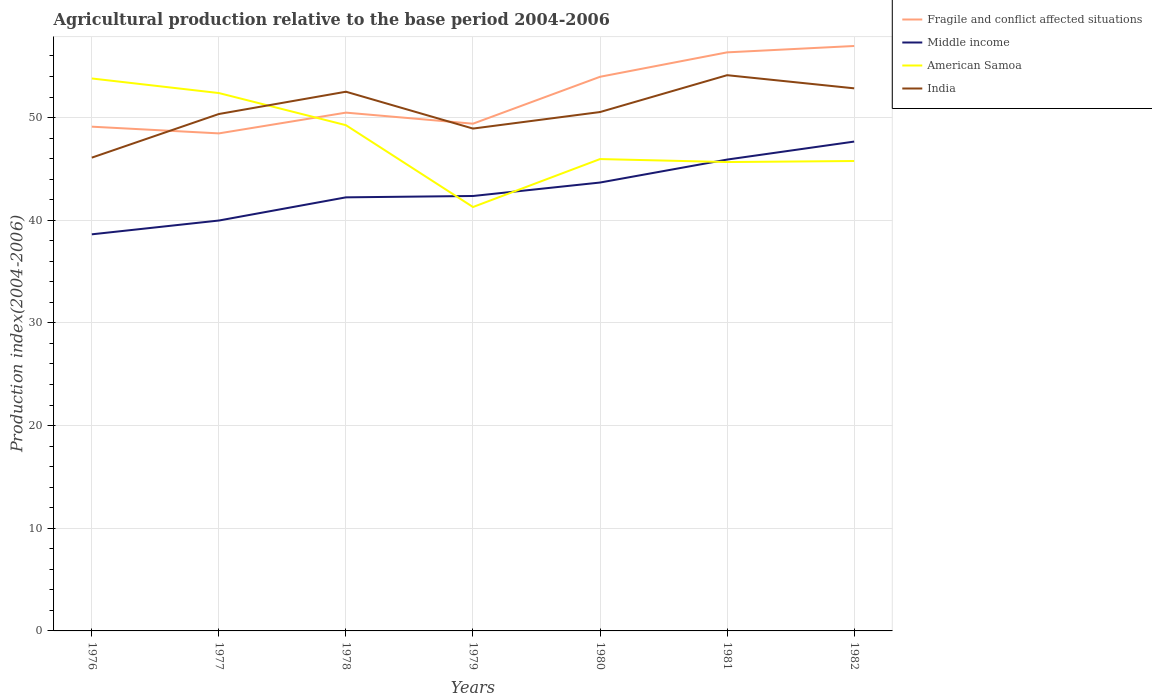Is the number of lines equal to the number of legend labels?
Provide a short and direct response. Yes. Across all years, what is the maximum agricultural production index in Middle income?
Offer a very short reply. 38.63. In which year was the agricultural production index in Middle income maximum?
Provide a succinct answer. 1976. What is the total agricultural production index in India in the graph?
Provide a short and direct response. -2.31. What is the difference between the highest and the second highest agricultural production index in Middle income?
Give a very brief answer. 9.03. How many lines are there?
Provide a succinct answer. 4. How many years are there in the graph?
Give a very brief answer. 7. What is the difference between two consecutive major ticks on the Y-axis?
Provide a short and direct response. 10. Where does the legend appear in the graph?
Your response must be concise. Top right. What is the title of the graph?
Offer a very short reply. Agricultural production relative to the base period 2004-2006. Does "Peru" appear as one of the legend labels in the graph?
Your answer should be compact. No. What is the label or title of the X-axis?
Make the answer very short. Years. What is the label or title of the Y-axis?
Your response must be concise. Production index(2004-2006). What is the Production index(2004-2006) in Fragile and conflict affected situations in 1976?
Make the answer very short. 49.11. What is the Production index(2004-2006) in Middle income in 1976?
Make the answer very short. 38.63. What is the Production index(2004-2006) of American Samoa in 1976?
Offer a very short reply. 53.81. What is the Production index(2004-2006) in India in 1976?
Your answer should be compact. 46.1. What is the Production index(2004-2006) of Fragile and conflict affected situations in 1977?
Keep it short and to the point. 48.46. What is the Production index(2004-2006) of Middle income in 1977?
Offer a terse response. 39.97. What is the Production index(2004-2006) in American Samoa in 1977?
Offer a terse response. 52.39. What is the Production index(2004-2006) of India in 1977?
Give a very brief answer. 50.35. What is the Production index(2004-2006) of Fragile and conflict affected situations in 1978?
Keep it short and to the point. 50.48. What is the Production index(2004-2006) in Middle income in 1978?
Ensure brevity in your answer.  42.23. What is the Production index(2004-2006) of American Samoa in 1978?
Make the answer very short. 49.26. What is the Production index(2004-2006) in India in 1978?
Ensure brevity in your answer.  52.52. What is the Production index(2004-2006) of Fragile and conflict affected situations in 1979?
Offer a terse response. 49.41. What is the Production index(2004-2006) in Middle income in 1979?
Offer a very short reply. 42.36. What is the Production index(2004-2006) of American Samoa in 1979?
Keep it short and to the point. 41.29. What is the Production index(2004-2006) of India in 1979?
Offer a terse response. 48.93. What is the Production index(2004-2006) in Fragile and conflict affected situations in 1980?
Provide a short and direct response. 53.98. What is the Production index(2004-2006) of Middle income in 1980?
Ensure brevity in your answer.  43.67. What is the Production index(2004-2006) of American Samoa in 1980?
Offer a terse response. 45.96. What is the Production index(2004-2006) in India in 1980?
Your answer should be compact. 50.54. What is the Production index(2004-2006) in Fragile and conflict affected situations in 1981?
Provide a short and direct response. 56.35. What is the Production index(2004-2006) in Middle income in 1981?
Offer a very short reply. 45.91. What is the Production index(2004-2006) in American Samoa in 1981?
Give a very brief answer. 45.67. What is the Production index(2004-2006) of India in 1981?
Give a very brief answer. 54.13. What is the Production index(2004-2006) in Fragile and conflict affected situations in 1982?
Give a very brief answer. 56.97. What is the Production index(2004-2006) of Middle income in 1982?
Your answer should be very brief. 47.66. What is the Production index(2004-2006) of American Samoa in 1982?
Give a very brief answer. 45.77. What is the Production index(2004-2006) in India in 1982?
Offer a terse response. 52.85. Across all years, what is the maximum Production index(2004-2006) of Fragile and conflict affected situations?
Give a very brief answer. 56.97. Across all years, what is the maximum Production index(2004-2006) in Middle income?
Your answer should be compact. 47.66. Across all years, what is the maximum Production index(2004-2006) of American Samoa?
Offer a very short reply. 53.81. Across all years, what is the maximum Production index(2004-2006) in India?
Offer a terse response. 54.13. Across all years, what is the minimum Production index(2004-2006) of Fragile and conflict affected situations?
Make the answer very short. 48.46. Across all years, what is the minimum Production index(2004-2006) in Middle income?
Your response must be concise. 38.63. Across all years, what is the minimum Production index(2004-2006) of American Samoa?
Ensure brevity in your answer.  41.29. Across all years, what is the minimum Production index(2004-2006) in India?
Give a very brief answer. 46.1. What is the total Production index(2004-2006) of Fragile and conflict affected situations in the graph?
Offer a terse response. 364.77. What is the total Production index(2004-2006) in Middle income in the graph?
Provide a short and direct response. 300.45. What is the total Production index(2004-2006) of American Samoa in the graph?
Keep it short and to the point. 334.15. What is the total Production index(2004-2006) of India in the graph?
Give a very brief answer. 355.42. What is the difference between the Production index(2004-2006) of Fragile and conflict affected situations in 1976 and that in 1977?
Ensure brevity in your answer.  0.65. What is the difference between the Production index(2004-2006) in Middle income in 1976 and that in 1977?
Make the answer very short. -1.34. What is the difference between the Production index(2004-2006) in American Samoa in 1976 and that in 1977?
Keep it short and to the point. 1.42. What is the difference between the Production index(2004-2006) of India in 1976 and that in 1977?
Provide a succinct answer. -4.25. What is the difference between the Production index(2004-2006) in Fragile and conflict affected situations in 1976 and that in 1978?
Your answer should be compact. -1.37. What is the difference between the Production index(2004-2006) in Middle income in 1976 and that in 1978?
Keep it short and to the point. -3.6. What is the difference between the Production index(2004-2006) of American Samoa in 1976 and that in 1978?
Ensure brevity in your answer.  4.55. What is the difference between the Production index(2004-2006) in India in 1976 and that in 1978?
Provide a short and direct response. -6.42. What is the difference between the Production index(2004-2006) of Fragile and conflict affected situations in 1976 and that in 1979?
Offer a terse response. -0.29. What is the difference between the Production index(2004-2006) in Middle income in 1976 and that in 1979?
Ensure brevity in your answer.  -3.73. What is the difference between the Production index(2004-2006) in American Samoa in 1976 and that in 1979?
Keep it short and to the point. 12.52. What is the difference between the Production index(2004-2006) of India in 1976 and that in 1979?
Keep it short and to the point. -2.83. What is the difference between the Production index(2004-2006) in Fragile and conflict affected situations in 1976 and that in 1980?
Provide a short and direct response. -4.86. What is the difference between the Production index(2004-2006) in Middle income in 1976 and that in 1980?
Give a very brief answer. -5.04. What is the difference between the Production index(2004-2006) in American Samoa in 1976 and that in 1980?
Provide a succinct answer. 7.85. What is the difference between the Production index(2004-2006) of India in 1976 and that in 1980?
Your answer should be compact. -4.44. What is the difference between the Production index(2004-2006) of Fragile and conflict affected situations in 1976 and that in 1981?
Keep it short and to the point. -7.24. What is the difference between the Production index(2004-2006) of Middle income in 1976 and that in 1981?
Offer a terse response. -7.28. What is the difference between the Production index(2004-2006) in American Samoa in 1976 and that in 1981?
Offer a very short reply. 8.14. What is the difference between the Production index(2004-2006) in India in 1976 and that in 1981?
Your response must be concise. -8.03. What is the difference between the Production index(2004-2006) of Fragile and conflict affected situations in 1976 and that in 1982?
Keep it short and to the point. -7.86. What is the difference between the Production index(2004-2006) of Middle income in 1976 and that in 1982?
Ensure brevity in your answer.  -9.03. What is the difference between the Production index(2004-2006) in American Samoa in 1976 and that in 1982?
Ensure brevity in your answer.  8.04. What is the difference between the Production index(2004-2006) in India in 1976 and that in 1982?
Provide a short and direct response. -6.75. What is the difference between the Production index(2004-2006) in Fragile and conflict affected situations in 1977 and that in 1978?
Your answer should be very brief. -2.02. What is the difference between the Production index(2004-2006) in Middle income in 1977 and that in 1978?
Provide a succinct answer. -2.26. What is the difference between the Production index(2004-2006) in American Samoa in 1977 and that in 1978?
Your response must be concise. 3.13. What is the difference between the Production index(2004-2006) of India in 1977 and that in 1978?
Give a very brief answer. -2.17. What is the difference between the Production index(2004-2006) in Fragile and conflict affected situations in 1977 and that in 1979?
Make the answer very short. -0.94. What is the difference between the Production index(2004-2006) of Middle income in 1977 and that in 1979?
Offer a terse response. -2.39. What is the difference between the Production index(2004-2006) in India in 1977 and that in 1979?
Ensure brevity in your answer.  1.42. What is the difference between the Production index(2004-2006) in Fragile and conflict affected situations in 1977 and that in 1980?
Offer a very short reply. -5.51. What is the difference between the Production index(2004-2006) in Middle income in 1977 and that in 1980?
Provide a succinct answer. -3.7. What is the difference between the Production index(2004-2006) of American Samoa in 1977 and that in 1980?
Make the answer very short. 6.43. What is the difference between the Production index(2004-2006) in India in 1977 and that in 1980?
Provide a succinct answer. -0.19. What is the difference between the Production index(2004-2006) of Fragile and conflict affected situations in 1977 and that in 1981?
Offer a very short reply. -7.89. What is the difference between the Production index(2004-2006) in Middle income in 1977 and that in 1981?
Ensure brevity in your answer.  -5.94. What is the difference between the Production index(2004-2006) in American Samoa in 1977 and that in 1981?
Make the answer very short. 6.72. What is the difference between the Production index(2004-2006) of India in 1977 and that in 1981?
Your answer should be very brief. -3.78. What is the difference between the Production index(2004-2006) of Fragile and conflict affected situations in 1977 and that in 1982?
Give a very brief answer. -8.51. What is the difference between the Production index(2004-2006) of Middle income in 1977 and that in 1982?
Offer a very short reply. -7.69. What is the difference between the Production index(2004-2006) of American Samoa in 1977 and that in 1982?
Ensure brevity in your answer.  6.62. What is the difference between the Production index(2004-2006) in Fragile and conflict affected situations in 1978 and that in 1979?
Keep it short and to the point. 1.08. What is the difference between the Production index(2004-2006) in Middle income in 1978 and that in 1979?
Give a very brief answer. -0.13. What is the difference between the Production index(2004-2006) of American Samoa in 1978 and that in 1979?
Keep it short and to the point. 7.97. What is the difference between the Production index(2004-2006) of India in 1978 and that in 1979?
Provide a succinct answer. 3.59. What is the difference between the Production index(2004-2006) of Fragile and conflict affected situations in 1978 and that in 1980?
Offer a terse response. -3.49. What is the difference between the Production index(2004-2006) of Middle income in 1978 and that in 1980?
Provide a short and direct response. -1.44. What is the difference between the Production index(2004-2006) of American Samoa in 1978 and that in 1980?
Give a very brief answer. 3.3. What is the difference between the Production index(2004-2006) in India in 1978 and that in 1980?
Offer a very short reply. 1.98. What is the difference between the Production index(2004-2006) of Fragile and conflict affected situations in 1978 and that in 1981?
Keep it short and to the point. -5.87. What is the difference between the Production index(2004-2006) of Middle income in 1978 and that in 1981?
Offer a very short reply. -3.68. What is the difference between the Production index(2004-2006) of American Samoa in 1978 and that in 1981?
Offer a very short reply. 3.59. What is the difference between the Production index(2004-2006) in India in 1978 and that in 1981?
Give a very brief answer. -1.61. What is the difference between the Production index(2004-2006) of Fragile and conflict affected situations in 1978 and that in 1982?
Give a very brief answer. -6.49. What is the difference between the Production index(2004-2006) of Middle income in 1978 and that in 1982?
Your response must be concise. -5.43. What is the difference between the Production index(2004-2006) of American Samoa in 1978 and that in 1982?
Your response must be concise. 3.49. What is the difference between the Production index(2004-2006) in India in 1978 and that in 1982?
Offer a terse response. -0.33. What is the difference between the Production index(2004-2006) of Fragile and conflict affected situations in 1979 and that in 1980?
Make the answer very short. -4.57. What is the difference between the Production index(2004-2006) in Middle income in 1979 and that in 1980?
Ensure brevity in your answer.  -1.31. What is the difference between the Production index(2004-2006) of American Samoa in 1979 and that in 1980?
Your answer should be very brief. -4.67. What is the difference between the Production index(2004-2006) of India in 1979 and that in 1980?
Provide a succinct answer. -1.61. What is the difference between the Production index(2004-2006) in Fragile and conflict affected situations in 1979 and that in 1981?
Your answer should be compact. -6.95. What is the difference between the Production index(2004-2006) of Middle income in 1979 and that in 1981?
Offer a terse response. -3.55. What is the difference between the Production index(2004-2006) of American Samoa in 1979 and that in 1981?
Offer a terse response. -4.38. What is the difference between the Production index(2004-2006) of Fragile and conflict affected situations in 1979 and that in 1982?
Your answer should be compact. -7.57. What is the difference between the Production index(2004-2006) of Middle income in 1979 and that in 1982?
Give a very brief answer. -5.3. What is the difference between the Production index(2004-2006) of American Samoa in 1979 and that in 1982?
Give a very brief answer. -4.48. What is the difference between the Production index(2004-2006) of India in 1979 and that in 1982?
Offer a terse response. -3.92. What is the difference between the Production index(2004-2006) in Fragile and conflict affected situations in 1980 and that in 1981?
Offer a very short reply. -2.38. What is the difference between the Production index(2004-2006) of Middle income in 1980 and that in 1981?
Keep it short and to the point. -2.24. What is the difference between the Production index(2004-2006) of American Samoa in 1980 and that in 1981?
Your answer should be very brief. 0.29. What is the difference between the Production index(2004-2006) in India in 1980 and that in 1981?
Give a very brief answer. -3.59. What is the difference between the Production index(2004-2006) of Fragile and conflict affected situations in 1980 and that in 1982?
Provide a short and direct response. -3. What is the difference between the Production index(2004-2006) of Middle income in 1980 and that in 1982?
Offer a terse response. -3.99. What is the difference between the Production index(2004-2006) of American Samoa in 1980 and that in 1982?
Offer a terse response. 0.19. What is the difference between the Production index(2004-2006) of India in 1980 and that in 1982?
Your answer should be very brief. -2.31. What is the difference between the Production index(2004-2006) in Fragile and conflict affected situations in 1981 and that in 1982?
Ensure brevity in your answer.  -0.62. What is the difference between the Production index(2004-2006) in Middle income in 1981 and that in 1982?
Keep it short and to the point. -1.75. What is the difference between the Production index(2004-2006) in India in 1981 and that in 1982?
Provide a succinct answer. 1.28. What is the difference between the Production index(2004-2006) in Fragile and conflict affected situations in 1976 and the Production index(2004-2006) in Middle income in 1977?
Offer a very short reply. 9.14. What is the difference between the Production index(2004-2006) in Fragile and conflict affected situations in 1976 and the Production index(2004-2006) in American Samoa in 1977?
Ensure brevity in your answer.  -3.28. What is the difference between the Production index(2004-2006) of Fragile and conflict affected situations in 1976 and the Production index(2004-2006) of India in 1977?
Give a very brief answer. -1.24. What is the difference between the Production index(2004-2006) of Middle income in 1976 and the Production index(2004-2006) of American Samoa in 1977?
Offer a terse response. -13.76. What is the difference between the Production index(2004-2006) of Middle income in 1976 and the Production index(2004-2006) of India in 1977?
Offer a terse response. -11.72. What is the difference between the Production index(2004-2006) of American Samoa in 1976 and the Production index(2004-2006) of India in 1977?
Offer a very short reply. 3.46. What is the difference between the Production index(2004-2006) of Fragile and conflict affected situations in 1976 and the Production index(2004-2006) of Middle income in 1978?
Keep it short and to the point. 6.88. What is the difference between the Production index(2004-2006) in Fragile and conflict affected situations in 1976 and the Production index(2004-2006) in American Samoa in 1978?
Your response must be concise. -0.15. What is the difference between the Production index(2004-2006) of Fragile and conflict affected situations in 1976 and the Production index(2004-2006) of India in 1978?
Your answer should be very brief. -3.41. What is the difference between the Production index(2004-2006) of Middle income in 1976 and the Production index(2004-2006) of American Samoa in 1978?
Offer a very short reply. -10.63. What is the difference between the Production index(2004-2006) in Middle income in 1976 and the Production index(2004-2006) in India in 1978?
Give a very brief answer. -13.89. What is the difference between the Production index(2004-2006) of American Samoa in 1976 and the Production index(2004-2006) of India in 1978?
Your answer should be very brief. 1.29. What is the difference between the Production index(2004-2006) in Fragile and conflict affected situations in 1976 and the Production index(2004-2006) in Middle income in 1979?
Offer a terse response. 6.75. What is the difference between the Production index(2004-2006) in Fragile and conflict affected situations in 1976 and the Production index(2004-2006) in American Samoa in 1979?
Your answer should be very brief. 7.82. What is the difference between the Production index(2004-2006) in Fragile and conflict affected situations in 1976 and the Production index(2004-2006) in India in 1979?
Make the answer very short. 0.18. What is the difference between the Production index(2004-2006) of Middle income in 1976 and the Production index(2004-2006) of American Samoa in 1979?
Offer a terse response. -2.66. What is the difference between the Production index(2004-2006) of Middle income in 1976 and the Production index(2004-2006) of India in 1979?
Offer a very short reply. -10.3. What is the difference between the Production index(2004-2006) of American Samoa in 1976 and the Production index(2004-2006) of India in 1979?
Your answer should be very brief. 4.88. What is the difference between the Production index(2004-2006) in Fragile and conflict affected situations in 1976 and the Production index(2004-2006) in Middle income in 1980?
Your response must be concise. 5.44. What is the difference between the Production index(2004-2006) in Fragile and conflict affected situations in 1976 and the Production index(2004-2006) in American Samoa in 1980?
Make the answer very short. 3.15. What is the difference between the Production index(2004-2006) of Fragile and conflict affected situations in 1976 and the Production index(2004-2006) of India in 1980?
Give a very brief answer. -1.43. What is the difference between the Production index(2004-2006) of Middle income in 1976 and the Production index(2004-2006) of American Samoa in 1980?
Your answer should be very brief. -7.33. What is the difference between the Production index(2004-2006) of Middle income in 1976 and the Production index(2004-2006) of India in 1980?
Give a very brief answer. -11.91. What is the difference between the Production index(2004-2006) of American Samoa in 1976 and the Production index(2004-2006) of India in 1980?
Ensure brevity in your answer.  3.27. What is the difference between the Production index(2004-2006) of Fragile and conflict affected situations in 1976 and the Production index(2004-2006) of Middle income in 1981?
Provide a succinct answer. 3.2. What is the difference between the Production index(2004-2006) in Fragile and conflict affected situations in 1976 and the Production index(2004-2006) in American Samoa in 1981?
Your answer should be very brief. 3.44. What is the difference between the Production index(2004-2006) of Fragile and conflict affected situations in 1976 and the Production index(2004-2006) of India in 1981?
Offer a terse response. -5.02. What is the difference between the Production index(2004-2006) in Middle income in 1976 and the Production index(2004-2006) in American Samoa in 1981?
Keep it short and to the point. -7.04. What is the difference between the Production index(2004-2006) in Middle income in 1976 and the Production index(2004-2006) in India in 1981?
Keep it short and to the point. -15.5. What is the difference between the Production index(2004-2006) in American Samoa in 1976 and the Production index(2004-2006) in India in 1981?
Provide a succinct answer. -0.32. What is the difference between the Production index(2004-2006) in Fragile and conflict affected situations in 1976 and the Production index(2004-2006) in Middle income in 1982?
Make the answer very short. 1.45. What is the difference between the Production index(2004-2006) in Fragile and conflict affected situations in 1976 and the Production index(2004-2006) in American Samoa in 1982?
Ensure brevity in your answer.  3.34. What is the difference between the Production index(2004-2006) of Fragile and conflict affected situations in 1976 and the Production index(2004-2006) of India in 1982?
Your answer should be very brief. -3.74. What is the difference between the Production index(2004-2006) in Middle income in 1976 and the Production index(2004-2006) in American Samoa in 1982?
Make the answer very short. -7.14. What is the difference between the Production index(2004-2006) of Middle income in 1976 and the Production index(2004-2006) of India in 1982?
Provide a succinct answer. -14.22. What is the difference between the Production index(2004-2006) in American Samoa in 1976 and the Production index(2004-2006) in India in 1982?
Keep it short and to the point. 0.96. What is the difference between the Production index(2004-2006) of Fragile and conflict affected situations in 1977 and the Production index(2004-2006) of Middle income in 1978?
Ensure brevity in your answer.  6.23. What is the difference between the Production index(2004-2006) in Fragile and conflict affected situations in 1977 and the Production index(2004-2006) in American Samoa in 1978?
Your answer should be very brief. -0.8. What is the difference between the Production index(2004-2006) in Fragile and conflict affected situations in 1977 and the Production index(2004-2006) in India in 1978?
Ensure brevity in your answer.  -4.06. What is the difference between the Production index(2004-2006) in Middle income in 1977 and the Production index(2004-2006) in American Samoa in 1978?
Provide a succinct answer. -9.29. What is the difference between the Production index(2004-2006) of Middle income in 1977 and the Production index(2004-2006) of India in 1978?
Offer a very short reply. -12.55. What is the difference between the Production index(2004-2006) of American Samoa in 1977 and the Production index(2004-2006) of India in 1978?
Your response must be concise. -0.13. What is the difference between the Production index(2004-2006) in Fragile and conflict affected situations in 1977 and the Production index(2004-2006) in Middle income in 1979?
Offer a terse response. 6.1. What is the difference between the Production index(2004-2006) in Fragile and conflict affected situations in 1977 and the Production index(2004-2006) in American Samoa in 1979?
Your response must be concise. 7.17. What is the difference between the Production index(2004-2006) in Fragile and conflict affected situations in 1977 and the Production index(2004-2006) in India in 1979?
Keep it short and to the point. -0.47. What is the difference between the Production index(2004-2006) of Middle income in 1977 and the Production index(2004-2006) of American Samoa in 1979?
Make the answer very short. -1.32. What is the difference between the Production index(2004-2006) in Middle income in 1977 and the Production index(2004-2006) in India in 1979?
Keep it short and to the point. -8.96. What is the difference between the Production index(2004-2006) in American Samoa in 1977 and the Production index(2004-2006) in India in 1979?
Your answer should be very brief. 3.46. What is the difference between the Production index(2004-2006) of Fragile and conflict affected situations in 1977 and the Production index(2004-2006) of Middle income in 1980?
Provide a short and direct response. 4.79. What is the difference between the Production index(2004-2006) in Fragile and conflict affected situations in 1977 and the Production index(2004-2006) in American Samoa in 1980?
Offer a very short reply. 2.5. What is the difference between the Production index(2004-2006) of Fragile and conflict affected situations in 1977 and the Production index(2004-2006) of India in 1980?
Your answer should be compact. -2.08. What is the difference between the Production index(2004-2006) in Middle income in 1977 and the Production index(2004-2006) in American Samoa in 1980?
Keep it short and to the point. -5.99. What is the difference between the Production index(2004-2006) in Middle income in 1977 and the Production index(2004-2006) in India in 1980?
Offer a terse response. -10.57. What is the difference between the Production index(2004-2006) in American Samoa in 1977 and the Production index(2004-2006) in India in 1980?
Offer a very short reply. 1.85. What is the difference between the Production index(2004-2006) of Fragile and conflict affected situations in 1977 and the Production index(2004-2006) of Middle income in 1981?
Offer a very short reply. 2.55. What is the difference between the Production index(2004-2006) of Fragile and conflict affected situations in 1977 and the Production index(2004-2006) of American Samoa in 1981?
Keep it short and to the point. 2.79. What is the difference between the Production index(2004-2006) of Fragile and conflict affected situations in 1977 and the Production index(2004-2006) of India in 1981?
Offer a terse response. -5.67. What is the difference between the Production index(2004-2006) in Middle income in 1977 and the Production index(2004-2006) in American Samoa in 1981?
Make the answer very short. -5.7. What is the difference between the Production index(2004-2006) of Middle income in 1977 and the Production index(2004-2006) of India in 1981?
Provide a succinct answer. -14.16. What is the difference between the Production index(2004-2006) of American Samoa in 1977 and the Production index(2004-2006) of India in 1981?
Keep it short and to the point. -1.74. What is the difference between the Production index(2004-2006) of Fragile and conflict affected situations in 1977 and the Production index(2004-2006) of Middle income in 1982?
Offer a terse response. 0.8. What is the difference between the Production index(2004-2006) of Fragile and conflict affected situations in 1977 and the Production index(2004-2006) of American Samoa in 1982?
Offer a terse response. 2.69. What is the difference between the Production index(2004-2006) of Fragile and conflict affected situations in 1977 and the Production index(2004-2006) of India in 1982?
Provide a short and direct response. -4.39. What is the difference between the Production index(2004-2006) of Middle income in 1977 and the Production index(2004-2006) of American Samoa in 1982?
Provide a succinct answer. -5.8. What is the difference between the Production index(2004-2006) in Middle income in 1977 and the Production index(2004-2006) in India in 1982?
Provide a short and direct response. -12.88. What is the difference between the Production index(2004-2006) of American Samoa in 1977 and the Production index(2004-2006) of India in 1982?
Ensure brevity in your answer.  -0.46. What is the difference between the Production index(2004-2006) of Fragile and conflict affected situations in 1978 and the Production index(2004-2006) of Middle income in 1979?
Offer a very short reply. 8.12. What is the difference between the Production index(2004-2006) in Fragile and conflict affected situations in 1978 and the Production index(2004-2006) in American Samoa in 1979?
Your answer should be very brief. 9.19. What is the difference between the Production index(2004-2006) in Fragile and conflict affected situations in 1978 and the Production index(2004-2006) in India in 1979?
Offer a very short reply. 1.55. What is the difference between the Production index(2004-2006) of Middle income in 1978 and the Production index(2004-2006) of American Samoa in 1979?
Provide a short and direct response. 0.94. What is the difference between the Production index(2004-2006) of Middle income in 1978 and the Production index(2004-2006) of India in 1979?
Provide a short and direct response. -6.7. What is the difference between the Production index(2004-2006) of American Samoa in 1978 and the Production index(2004-2006) of India in 1979?
Make the answer very short. 0.33. What is the difference between the Production index(2004-2006) of Fragile and conflict affected situations in 1978 and the Production index(2004-2006) of Middle income in 1980?
Your answer should be compact. 6.81. What is the difference between the Production index(2004-2006) in Fragile and conflict affected situations in 1978 and the Production index(2004-2006) in American Samoa in 1980?
Keep it short and to the point. 4.52. What is the difference between the Production index(2004-2006) of Fragile and conflict affected situations in 1978 and the Production index(2004-2006) of India in 1980?
Ensure brevity in your answer.  -0.06. What is the difference between the Production index(2004-2006) of Middle income in 1978 and the Production index(2004-2006) of American Samoa in 1980?
Make the answer very short. -3.73. What is the difference between the Production index(2004-2006) of Middle income in 1978 and the Production index(2004-2006) of India in 1980?
Keep it short and to the point. -8.31. What is the difference between the Production index(2004-2006) in American Samoa in 1978 and the Production index(2004-2006) in India in 1980?
Offer a very short reply. -1.28. What is the difference between the Production index(2004-2006) of Fragile and conflict affected situations in 1978 and the Production index(2004-2006) of Middle income in 1981?
Offer a very short reply. 4.57. What is the difference between the Production index(2004-2006) in Fragile and conflict affected situations in 1978 and the Production index(2004-2006) in American Samoa in 1981?
Your answer should be compact. 4.81. What is the difference between the Production index(2004-2006) of Fragile and conflict affected situations in 1978 and the Production index(2004-2006) of India in 1981?
Your response must be concise. -3.65. What is the difference between the Production index(2004-2006) of Middle income in 1978 and the Production index(2004-2006) of American Samoa in 1981?
Make the answer very short. -3.44. What is the difference between the Production index(2004-2006) in Middle income in 1978 and the Production index(2004-2006) in India in 1981?
Offer a terse response. -11.9. What is the difference between the Production index(2004-2006) of American Samoa in 1978 and the Production index(2004-2006) of India in 1981?
Offer a terse response. -4.87. What is the difference between the Production index(2004-2006) in Fragile and conflict affected situations in 1978 and the Production index(2004-2006) in Middle income in 1982?
Provide a short and direct response. 2.82. What is the difference between the Production index(2004-2006) of Fragile and conflict affected situations in 1978 and the Production index(2004-2006) of American Samoa in 1982?
Keep it short and to the point. 4.71. What is the difference between the Production index(2004-2006) in Fragile and conflict affected situations in 1978 and the Production index(2004-2006) in India in 1982?
Provide a short and direct response. -2.37. What is the difference between the Production index(2004-2006) of Middle income in 1978 and the Production index(2004-2006) of American Samoa in 1982?
Ensure brevity in your answer.  -3.54. What is the difference between the Production index(2004-2006) of Middle income in 1978 and the Production index(2004-2006) of India in 1982?
Provide a succinct answer. -10.62. What is the difference between the Production index(2004-2006) in American Samoa in 1978 and the Production index(2004-2006) in India in 1982?
Keep it short and to the point. -3.59. What is the difference between the Production index(2004-2006) of Fragile and conflict affected situations in 1979 and the Production index(2004-2006) of Middle income in 1980?
Provide a succinct answer. 5.73. What is the difference between the Production index(2004-2006) in Fragile and conflict affected situations in 1979 and the Production index(2004-2006) in American Samoa in 1980?
Provide a short and direct response. 3.45. What is the difference between the Production index(2004-2006) in Fragile and conflict affected situations in 1979 and the Production index(2004-2006) in India in 1980?
Ensure brevity in your answer.  -1.13. What is the difference between the Production index(2004-2006) of Middle income in 1979 and the Production index(2004-2006) of American Samoa in 1980?
Make the answer very short. -3.6. What is the difference between the Production index(2004-2006) in Middle income in 1979 and the Production index(2004-2006) in India in 1980?
Offer a very short reply. -8.18. What is the difference between the Production index(2004-2006) of American Samoa in 1979 and the Production index(2004-2006) of India in 1980?
Give a very brief answer. -9.25. What is the difference between the Production index(2004-2006) of Fragile and conflict affected situations in 1979 and the Production index(2004-2006) of Middle income in 1981?
Offer a very short reply. 3.49. What is the difference between the Production index(2004-2006) in Fragile and conflict affected situations in 1979 and the Production index(2004-2006) in American Samoa in 1981?
Offer a terse response. 3.74. What is the difference between the Production index(2004-2006) in Fragile and conflict affected situations in 1979 and the Production index(2004-2006) in India in 1981?
Offer a very short reply. -4.72. What is the difference between the Production index(2004-2006) of Middle income in 1979 and the Production index(2004-2006) of American Samoa in 1981?
Your answer should be compact. -3.31. What is the difference between the Production index(2004-2006) of Middle income in 1979 and the Production index(2004-2006) of India in 1981?
Offer a terse response. -11.77. What is the difference between the Production index(2004-2006) in American Samoa in 1979 and the Production index(2004-2006) in India in 1981?
Provide a succinct answer. -12.84. What is the difference between the Production index(2004-2006) of Fragile and conflict affected situations in 1979 and the Production index(2004-2006) of Middle income in 1982?
Your answer should be very brief. 1.74. What is the difference between the Production index(2004-2006) in Fragile and conflict affected situations in 1979 and the Production index(2004-2006) in American Samoa in 1982?
Ensure brevity in your answer.  3.64. What is the difference between the Production index(2004-2006) of Fragile and conflict affected situations in 1979 and the Production index(2004-2006) of India in 1982?
Your answer should be very brief. -3.44. What is the difference between the Production index(2004-2006) in Middle income in 1979 and the Production index(2004-2006) in American Samoa in 1982?
Provide a succinct answer. -3.41. What is the difference between the Production index(2004-2006) of Middle income in 1979 and the Production index(2004-2006) of India in 1982?
Give a very brief answer. -10.49. What is the difference between the Production index(2004-2006) in American Samoa in 1979 and the Production index(2004-2006) in India in 1982?
Offer a very short reply. -11.56. What is the difference between the Production index(2004-2006) in Fragile and conflict affected situations in 1980 and the Production index(2004-2006) in Middle income in 1981?
Provide a short and direct response. 8.06. What is the difference between the Production index(2004-2006) of Fragile and conflict affected situations in 1980 and the Production index(2004-2006) of American Samoa in 1981?
Your answer should be compact. 8.31. What is the difference between the Production index(2004-2006) in Fragile and conflict affected situations in 1980 and the Production index(2004-2006) in India in 1981?
Your answer should be compact. -0.15. What is the difference between the Production index(2004-2006) of Middle income in 1980 and the Production index(2004-2006) of American Samoa in 1981?
Your answer should be very brief. -2. What is the difference between the Production index(2004-2006) in Middle income in 1980 and the Production index(2004-2006) in India in 1981?
Your answer should be very brief. -10.46. What is the difference between the Production index(2004-2006) of American Samoa in 1980 and the Production index(2004-2006) of India in 1981?
Offer a very short reply. -8.17. What is the difference between the Production index(2004-2006) in Fragile and conflict affected situations in 1980 and the Production index(2004-2006) in Middle income in 1982?
Keep it short and to the point. 6.31. What is the difference between the Production index(2004-2006) of Fragile and conflict affected situations in 1980 and the Production index(2004-2006) of American Samoa in 1982?
Give a very brief answer. 8.21. What is the difference between the Production index(2004-2006) in Fragile and conflict affected situations in 1980 and the Production index(2004-2006) in India in 1982?
Provide a succinct answer. 1.13. What is the difference between the Production index(2004-2006) in Middle income in 1980 and the Production index(2004-2006) in American Samoa in 1982?
Offer a terse response. -2.1. What is the difference between the Production index(2004-2006) of Middle income in 1980 and the Production index(2004-2006) of India in 1982?
Your response must be concise. -9.18. What is the difference between the Production index(2004-2006) in American Samoa in 1980 and the Production index(2004-2006) in India in 1982?
Ensure brevity in your answer.  -6.89. What is the difference between the Production index(2004-2006) of Fragile and conflict affected situations in 1981 and the Production index(2004-2006) of Middle income in 1982?
Give a very brief answer. 8.69. What is the difference between the Production index(2004-2006) of Fragile and conflict affected situations in 1981 and the Production index(2004-2006) of American Samoa in 1982?
Offer a terse response. 10.58. What is the difference between the Production index(2004-2006) in Fragile and conflict affected situations in 1981 and the Production index(2004-2006) in India in 1982?
Ensure brevity in your answer.  3.5. What is the difference between the Production index(2004-2006) in Middle income in 1981 and the Production index(2004-2006) in American Samoa in 1982?
Your answer should be very brief. 0.14. What is the difference between the Production index(2004-2006) in Middle income in 1981 and the Production index(2004-2006) in India in 1982?
Keep it short and to the point. -6.94. What is the difference between the Production index(2004-2006) of American Samoa in 1981 and the Production index(2004-2006) of India in 1982?
Your answer should be compact. -7.18. What is the average Production index(2004-2006) in Fragile and conflict affected situations per year?
Your answer should be very brief. 52.11. What is the average Production index(2004-2006) in Middle income per year?
Give a very brief answer. 42.92. What is the average Production index(2004-2006) of American Samoa per year?
Your answer should be very brief. 47.74. What is the average Production index(2004-2006) in India per year?
Your answer should be very brief. 50.77. In the year 1976, what is the difference between the Production index(2004-2006) in Fragile and conflict affected situations and Production index(2004-2006) in Middle income?
Your answer should be compact. 10.48. In the year 1976, what is the difference between the Production index(2004-2006) of Fragile and conflict affected situations and Production index(2004-2006) of American Samoa?
Offer a very short reply. -4.7. In the year 1976, what is the difference between the Production index(2004-2006) in Fragile and conflict affected situations and Production index(2004-2006) in India?
Provide a succinct answer. 3.01. In the year 1976, what is the difference between the Production index(2004-2006) of Middle income and Production index(2004-2006) of American Samoa?
Your answer should be compact. -15.18. In the year 1976, what is the difference between the Production index(2004-2006) of Middle income and Production index(2004-2006) of India?
Your response must be concise. -7.47. In the year 1976, what is the difference between the Production index(2004-2006) of American Samoa and Production index(2004-2006) of India?
Offer a terse response. 7.71. In the year 1977, what is the difference between the Production index(2004-2006) of Fragile and conflict affected situations and Production index(2004-2006) of Middle income?
Your answer should be compact. 8.49. In the year 1977, what is the difference between the Production index(2004-2006) of Fragile and conflict affected situations and Production index(2004-2006) of American Samoa?
Provide a succinct answer. -3.93. In the year 1977, what is the difference between the Production index(2004-2006) of Fragile and conflict affected situations and Production index(2004-2006) of India?
Your answer should be compact. -1.89. In the year 1977, what is the difference between the Production index(2004-2006) in Middle income and Production index(2004-2006) in American Samoa?
Provide a short and direct response. -12.42. In the year 1977, what is the difference between the Production index(2004-2006) in Middle income and Production index(2004-2006) in India?
Provide a short and direct response. -10.38. In the year 1977, what is the difference between the Production index(2004-2006) of American Samoa and Production index(2004-2006) of India?
Keep it short and to the point. 2.04. In the year 1978, what is the difference between the Production index(2004-2006) of Fragile and conflict affected situations and Production index(2004-2006) of Middle income?
Make the answer very short. 8.25. In the year 1978, what is the difference between the Production index(2004-2006) in Fragile and conflict affected situations and Production index(2004-2006) in American Samoa?
Offer a terse response. 1.22. In the year 1978, what is the difference between the Production index(2004-2006) in Fragile and conflict affected situations and Production index(2004-2006) in India?
Provide a succinct answer. -2.04. In the year 1978, what is the difference between the Production index(2004-2006) in Middle income and Production index(2004-2006) in American Samoa?
Your answer should be very brief. -7.03. In the year 1978, what is the difference between the Production index(2004-2006) in Middle income and Production index(2004-2006) in India?
Keep it short and to the point. -10.29. In the year 1978, what is the difference between the Production index(2004-2006) in American Samoa and Production index(2004-2006) in India?
Give a very brief answer. -3.26. In the year 1979, what is the difference between the Production index(2004-2006) in Fragile and conflict affected situations and Production index(2004-2006) in Middle income?
Give a very brief answer. 7.04. In the year 1979, what is the difference between the Production index(2004-2006) in Fragile and conflict affected situations and Production index(2004-2006) in American Samoa?
Provide a short and direct response. 8.12. In the year 1979, what is the difference between the Production index(2004-2006) of Fragile and conflict affected situations and Production index(2004-2006) of India?
Your response must be concise. 0.48. In the year 1979, what is the difference between the Production index(2004-2006) in Middle income and Production index(2004-2006) in American Samoa?
Offer a terse response. 1.07. In the year 1979, what is the difference between the Production index(2004-2006) in Middle income and Production index(2004-2006) in India?
Give a very brief answer. -6.57. In the year 1979, what is the difference between the Production index(2004-2006) of American Samoa and Production index(2004-2006) of India?
Make the answer very short. -7.64. In the year 1980, what is the difference between the Production index(2004-2006) in Fragile and conflict affected situations and Production index(2004-2006) in Middle income?
Offer a terse response. 10.3. In the year 1980, what is the difference between the Production index(2004-2006) in Fragile and conflict affected situations and Production index(2004-2006) in American Samoa?
Provide a short and direct response. 8.02. In the year 1980, what is the difference between the Production index(2004-2006) of Fragile and conflict affected situations and Production index(2004-2006) of India?
Give a very brief answer. 3.44. In the year 1980, what is the difference between the Production index(2004-2006) in Middle income and Production index(2004-2006) in American Samoa?
Offer a terse response. -2.29. In the year 1980, what is the difference between the Production index(2004-2006) of Middle income and Production index(2004-2006) of India?
Your answer should be compact. -6.87. In the year 1980, what is the difference between the Production index(2004-2006) in American Samoa and Production index(2004-2006) in India?
Keep it short and to the point. -4.58. In the year 1981, what is the difference between the Production index(2004-2006) of Fragile and conflict affected situations and Production index(2004-2006) of Middle income?
Keep it short and to the point. 10.44. In the year 1981, what is the difference between the Production index(2004-2006) of Fragile and conflict affected situations and Production index(2004-2006) of American Samoa?
Give a very brief answer. 10.68. In the year 1981, what is the difference between the Production index(2004-2006) in Fragile and conflict affected situations and Production index(2004-2006) in India?
Keep it short and to the point. 2.22. In the year 1981, what is the difference between the Production index(2004-2006) in Middle income and Production index(2004-2006) in American Samoa?
Offer a very short reply. 0.24. In the year 1981, what is the difference between the Production index(2004-2006) of Middle income and Production index(2004-2006) of India?
Provide a short and direct response. -8.22. In the year 1981, what is the difference between the Production index(2004-2006) in American Samoa and Production index(2004-2006) in India?
Offer a terse response. -8.46. In the year 1982, what is the difference between the Production index(2004-2006) in Fragile and conflict affected situations and Production index(2004-2006) in Middle income?
Your answer should be very brief. 9.31. In the year 1982, what is the difference between the Production index(2004-2006) in Fragile and conflict affected situations and Production index(2004-2006) in American Samoa?
Offer a terse response. 11.2. In the year 1982, what is the difference between the Production index(2004-2006) in Fragile and conflict affected situations and Production index(2004-2006) in India?
Your response must be concise. 4.12. In the year 1982, what is the difference between the Production index(2004-2006) of Middle income and Production index(2004-2006) of American Samoa?
Offer a terse response. 1.89. In the year 1982, what is the difference between the Production index(2004-2006) in Middle income and Production index(2004-2006) in India?
Provide a short and direct response. -5.19. In the year 1982, what is the difference between the Production index(2004-2006) in American Samoa and Production index(2004-2006) in India?
Your answer should be very brief. -7.08. What is the ratio of the Production index(2004-2006) of Fragile and conflict affected situations in 1976 to that in 1977?
Offer a very short reply. 1.01. What is the ratio of the Production index(2004-2006) of Middle income in 1976 to that in 1977?
Offer a very short reply. 0.97. What is the ratio of the Production index(2004-2006) in American Samoa in 1976 to that in 1977?
Keep it short and to the point. 1.03. What is the ratio of the Production index(2004-2006) of India in 1976 to that in 1977?
Your answer should be very brief. 0.92. What is the ratio of the Production index(2004-2006) in Fragile and conflict affected situations in 1976 to that in 1978?
Give a very brief answer. 0.97. What is the ratio of the Production index(2004-2006) of Middle income in 1976 to that in 1978?
Offer a very short reply. 0.91. What is the ratio of the Production index(2004-2006) in American Samoa in 1976 to that in 1978?
Offer a terse response. 1.09. What is the ratio of the Production index(2004-2006) of India in 1976 to that in 1978?
Ensure brevity in your answer.  0.88. What is the ratio of the Production index(2004-2006) of Fragile and conflict affected situations in 1976 to that in 1979?
Make the answer very short. 0.99. What is the ratio of the Production index(2004-2006) in Middle income in 1976 to that in 1979?
Provide a succinct answer. 0.91. What is the ratio of the Production index(2004-2006) of American Samoa in 1976 to that in 1979?
Give a very brief answer. 1.3. What is the ratio of the Production index(2004-2006) in India in 1976 to that in 1979?
Keep it short and to the point. 0.94. What is the ratio of the Production index(2004-2006) of Fragile and conflict affected situations in 1976 to that in 1980?
Ensure brevity in your answer.  0.91. What is the ratio of the Production index(2004-2006) of Middle income in 1976 to that in 1980?
Provide a succinct answer. 0.88. What is the ratio of the Production index(2004-2006) of American Samoa in 1976 to that in 1980?
Keep it short and to the point. 1.17. What is the ratio of the Production index(2004-2006) of India in 1976 to that in 1980?
Your answer should be compact. 0.91. What is the ratio of the Production index(2004-2006) in Fragile and conflict affected situations in 1976 to that in 1981?
Ensure brevity in your answer.  0.87. What is the ratio of the Production index(2004-2006) of Middle income in 1976 to that in 1981?
Your answer should be compact. 0.84. What is the ratio of the Production index(2004-2006) of American Samoa in 1976 to that in 1981?
Provide a succinct answer. 1.18. What is the ratio of the Production index(2004-2006) in India in 1976 to that in 1981?
Make the answer very short. 0.85. What is the ratio of the Production index(2004-2006) in Fragile and conflict affected situations in 1976 to that in 1982?
Give a very brief answer. 0.86. What is the ratio of the Production index(2004-2006) of Middle income in 1976 to that in 1982?
Ensure brevity in your answer.  0.81. What is the ratio of the Production index(2004-2006) in American Samoa in 1976 to that in 1982?
Keep it short and to the point. 1.18. What is the ratio of the Production index(2004-2006) of India in 1976 to that in 1982?
Offer a very short reply. 0.87. What is the ratio of the Production index(2004-2006) in Fragile and conflict affected situations in 1977 to that in 1978?
Provide a short and direct response. 0.96. What is the ratio of the Production index(2004-2006) in Middle income in 1977 to that in 1978?
Give a very brief answer. 0.95. What is the ratio of the Production index(2004-2006) of American Samoa in 1977 to that in 1978?
Your response must be concise. 1.06. What is the ratio of the Production index(2004-2006) in India in 1977 to that in 1978?
Offer a terse response. 0.96. What is the ratio of the Production index(2004-2006) in Fragile and conflict affected situations in 1977 to that in 1979?
Your answer should be compact. 0.98. What is the ratio of the Production index(2004-2006) in Middle income in 1977 to that in 1979?
Offer a very short reply. 0.94. What is the ratio of the Production index(2004-2006) of American Samoa in 1977 to that in 1979?
Provide a succinct answer. 1.27. What is the ratio of the Production index(2004-2006) in India in 1977 to that in 1979?
Offer a very short reply. 1.03. What is the ratio of the Production index(2004-2006) of Fragile and conflict affected situations in 1977 to that in 1980?
Your answer should be very brief. 0.9. What is the ratio of the Production index(2004-2006) of Middle income in 1977 to that in 1980?
Your answer should be compact. 0.92. What is the ratio of the Production index(2004-2006) in American Samoa in 1977 to that in 1980?
Offer a terse response. 1.14. What is the ratio of the Production index(2004-2006) of Fragile and conflict affected situations in 1977 to that in 1981?
Keep it short and to the point. 0.86. What is the ratio of the Production index(2004-2006) of Middle income in 1977 to that in 1981?
Ensure brevity in your answer.  0.87. What is the ratio of the Production index(2004-2006) of American Samoa in 1977 to that in 1981?
Offer a terse response. 1.15. What is the ratio of the Production index(2004-2006) of India in 1977 to that in 1981?
Your response must be concise. 0.93. What is the ratio of the Production index(2004-2006) of Fragile and conflict affected situations in 1977 to that in 1982?
Your response must be concise. 0.85. What is the ratio of the Production index(2004-2006) of Middle income in 1977 to that in 1982?
Your answer should be compact. 0.84. What is the ratio of the Production index(2004-2006) of American Samoa in 1977 to that in 1982?
Offer a very short reply. 1.14. What is the ratio of the Production index(2004-2006) of India in 1977 to that in 1982?
Give a very brief answer. 0.95. What is the ratio of the Production index(2004-2006) of Fragile and conflict affected situations in 1978 to that in 1979?
Offer a terse response. 1.02. What is the ratio of the Production index(2004-2006) in Middle income in 1978 to that in 1979?
Offer a very short reply. 1. What is the ratio of the Production index(2004-2006) of American Samoa in 1978 to that in 1979?
Make the answer very short. 1.19. What is the ratio of the Production index(2004-2006) of India in 1978 to that in 1979?
Give a very brief answer. 1.07. What is the ratio of the Production index(2004-2006) of Fragile and conflict affected situations in 1978 to that in 1980?
Offer a very short reply. 0.94. What is the ratio of the Production index(2004-2006) of American Samoa in 1978 to that in 1980?
Provide a succinct answer. 1.07. What is the ratio of the Production index(2004-2006) in India in 1978 to that in 1980?
Your answer should be compact. 1.04. What is the ratio of the Production index(2004-2006) of Fragile and conflict affected situations in 1978 to that in 1981?
Your response must be concise. 0.9. What is the ratio of the Production index(2004-2006) of Middle income in 1978 to that in 1981?
Your response must be concise. 0.92. What is the ratio of the Production index(2004-2006) of American Samoa in 1978 to that in 1981?
Offer a terse response. 1.08. What is the ratio of the Production index(2004-2006) in India in 1978 to that in 1981?
Your answer should be very brief. 0.97. What is the ratio of the Production index(2004-2006) in Fragile and conflict affected situations in 1978 to that in 1982?
Ensure brevity in your answer.  0.89. What is the ratio of the Production index(2004-2006) in Middle income in 1978 to that in 1982?
Your answer should be compact. 0.89. What is the ratio of the Production index(2004-2006) of American Samoa in 1978 to that in 1982?
Make the answer very short. 1.08. What is the ratio of the Production index(2004-2006) in India in 1978 to that in 1982?
Your response must be concise. 0.99. What is the ratio of the Production index(2004-2006) in Fragile and conflict affected situations in 1979 to that in 1980?
Keep it short and to the point. 0.92. What is the ratio of the Production index(2004-2006) in Middle income in 1979 to that in 1980?
Your answer should be compact. 0.97. What is the ratio of the Production index(2004-2006) of American Samoa in 1979 to that in 1980?
Make the answer very short. 0.9. What is the ratio of the Production index(2004-2006) of India in 1979 to that in 1980?
Your answer should be compact. 0.97. What is the ratio of the Production index(2004-2006) of Fragile and conflict affected situations in 1979 to that in 1981?
Provide a short and direct response. 0.88. What is the ratio of the Production index(2004-2006) of Middle income in 1979 to that in 1981?
Your answer should be compact. 0.92. What is the ratio of the Production index(2004-2006) of American Samoa in 1979 to that in 1981?
Offer a terse response. 0.9. What is the ratio of the Production index(2004-2006) of India in 1979 to that in 1981?
Offer a terse response. 0.9. What is the ratio of the Production index(2004-2006) in Fragile and conflict affected situations in 1979 to that in 1982?
Keep it short and to the point. 0.87. What is the ratio of the Production index(2004-2006) of Middle income in 1979 to that in 1982?
Your answer should be very brief. 0.89. What is the ratio of the Production index(2004-2006) in American Samoa in 1979 to that in 1982?
Give a very brief answer. 0.9. What is the ratio of the Production index(2004-2006) in India in 1979 to that in 1982?
Offer a terse response. 0.93. What is the ratio of the Production index(2004-2006) of Fragile and conflict affected situations in 1980 to that in 1981?
Offer a very short reply. 0.96. What is the ratio of the Production index(2004-2006) in Middle income in 1980 to that in 1981?
Give a very brief answer. 0.95. What is the ratio of the Production index(2004-2006) in American Samoa in 1980 to that in 1981?
Provide a succinct answer. 1.01. What is the ratio of the Production index(2004-2006) in India in 1980 to that in 1981?
Make the answer very short. 0.93. What is the ratio of the Production index(2004-2006) of Middle income in 1980 to that in 1982?
Offer a terse response. 0.92. What is the ratio of the Production index(2004-2006) in India in 1980 to that in 1982?
Provide a succinct answer. 0.96. What is the ratio of the Production index(2004-2006) of Middle income in 1981 to that in 1982?
Offer a very short reply. 0.96. What is the ratio of the Production index(2004-2006) of American Samoa in 1981 to that in 1982?
Provide a succinct answer. 1. What is the ratio of the Production index(2004-2006) in India in 1981 to that in 1982?
Offer a very short reply. 1.02. What is the difference between the highest and the second highest Production index(2004-2006) of Fragile and conflict affected situations?
Ensure brevity in your answer.  0.62. What is the difference between the highest and the second highest Production index(2004-2006) of Middle income?
Provide a succinct answer. 1.75. What is the difference between the highest and the second highest Production index(2004-2006) in American Samoa?
Offer a very short reply. 1.42. What is the difference between the highest and the second highest Production index(2004-2006) of India?
Your answer should be compact. 1.28. What is the difference between the highest and the lowest Production index(2004-2006) in Fragile and conflict affected situations?
Give a very brief answer. 8.51. What is the difference between the highest and the lowest Production index(2004-2006) in Middle income?
Provide a succinct answer. 9.03. What is the difference between the highest and the lowest Production index(2004-2006) in American Samoa?
Offer a very short reply. 12.52. What is the difference between the highest and the lowest Production index(2004-2006) in India?
Provide a succinct answer. 8.03. 